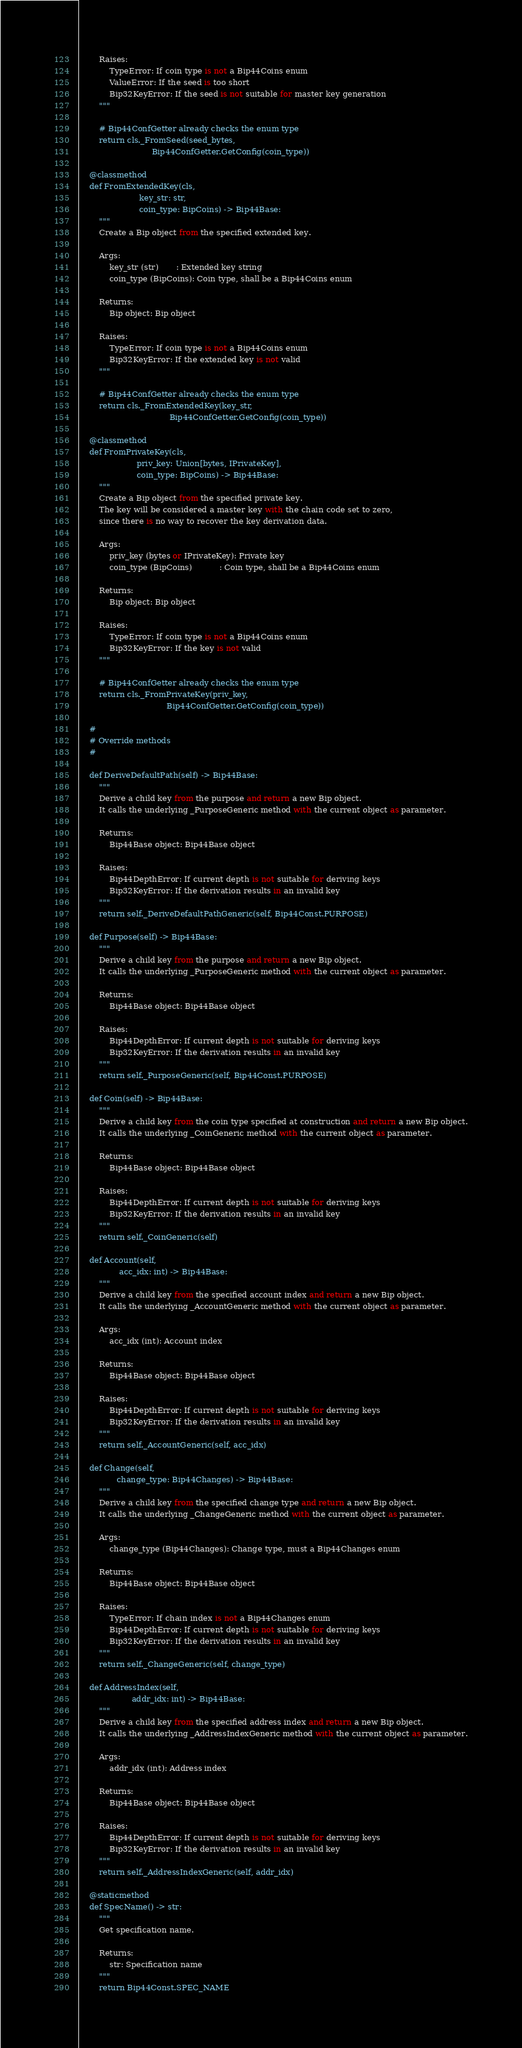<code> <loc_0><loc_0><loc_500><loc_500><_Python_>
        Raises:
            TypeError: If coin type is not a Bip44Coins enum
            ValueError: If the seed is too short
            Bip32KeyError: If the seed is not suitable for master key generation
        """

        # Bip44ConfGetter already checks the enum type
        return cls._FromSeed(seed_bytes,
                             Bip44ConfGetter.GetConfig(coin_type))

    @classmethod
    def FromExtendedKey(cls,
                        key_str: str,
                        coin_type: BipCoins) -> Bip44Base:
        """
        Create a Bip object from the specified extended key.

        Args:
            key_str (str)       : Extended key string
            coin_type (BipCoins): Coin type, shall be a Bip44Coins enum

        Returns:
            Bip object: Bip object

        Raises:
            TypeError: If coin type is not a Bip44Coins enum
            Bip32KeyError: If the extended key is not valid
        """

        # Bip44ConfGetter already checks the enum type
        return cls._FromExtendedKey(key_str,
                                    Bip44ConfGetter.GetConfig(coin_type))

    @classmethod
    def FromPrivateKey(cls,
                       priv_key: Union[bytes, IPrivateKey],
                       coin_type: BipCoins) -> Bip44Base:
        """
        Create a Bip object from the specified private key.
        The key will be considered a master key with the chain code set to zero,
        since there is no way to recover the key derivation data.

        Args:
            priv_key (bytes or IPrivateKey): Private key
            coin_type (BipCoins)           : Coin type, shall be a Bip44Coins enum

        Returns:
            Bip object: Bip object

        Raises:
            TypeError: If coin type is not a Bip44Coins enum
            Bip32KeyError: If the key is not valid
        """

        # Bip44ConfGetter already checks the enum type
        return cls._FromPrivateKey(priv_key,
                                   Bip44ConfGetter.GetConfig(coin_type))

    #
    # Override methods
    #

    def DeriveDefaultPath(self) -> Bip44Base:
        """
        Derive a child key from the purpose and return a new Bip object.
        It calls the underlying _PurposeGeneric method with the current object as parameter.

        Returns:
            Bip44Base object: Bip44Base object

        Raises:
            Bip44DepthError: If current depth is not suitable for deriving keys
            Bip32KeyError: If the derivation results in an invalid key
        """
        return self._DeriveDefaultPathGeneric(self, Bip44Const.PURPOSE)

    def Purpose(self) -> Bip44Base:
        """
        Derive a child key from the purpose and return a new Bip object.
        It calls the underlying _PurposeGeneric method with the current object as parameter.

        Returns:
            Bip44Base object: Bip44Base object

        Raises:
            Bip44DepthError: If current depth is not suitable for deriving keys
            Bip32KeyError: If the derivation results in an invalid key
        """
        return self._PurposeGeneric(self, Bip44Const.PURPOSE)

    def Coin(self) -> Bip44Base:
        """
        Derive a child key from the coin type specified at construction and return a new Bip object.
        It calls the underlying _CoinGeneric method with the current object as parameter.

        Returns:
            Bip44Base object: Bip44Base object

        Raises:
            Bip44DepthError: If current depth is not suitable for deriving keys
            Bip32KeyError: If the derivation results in an invalid key
        """
        return self._CoinGeneric(self)

    def Account(self,
                acc_idx: int) -> Bip44Base:
        """
        Derive a child key from the specified account index and return a new Bip object.
        It calls the underlying _AccountGeneric method with the current object as parameter.

        Args:
            acc_idx (int): Account index

        Returns:
            Bip44Base object: Bip44Base object

        Raises:
            Bip44DepthError: If current depth is not suitable for deriving keys
            Bip32KeyError: If the derivation results in an invalid key
        """
        return self._AccountGeneric(self, acc_idx)

    def Change(self,
               change_type: Bip44Changes) -> Bip44Base:
        """
        Derive a child key from the specified change type and return a new Bip object.
        It calls the underlying _ChangeGeneric method with the current object as parameter.

        Args:
            change_type (Bip44Changes): Change type, must a Bip44Changes enum

        Returns:
            Bip44Base object: Bip44Base object

        Raises:
            TypeError: If chain index is not a Bip44Changes enum
            Bip44DepthError: If current depth is not suitable for deriving keys
            Bip32KeyError: If the derivation results in an invalid key
        """
        return self._ChangeGeneric(self, change_type)

    def AddressIndex(self,
                     addr_idx: int) -> Bip44Base:
        """
        Derive a child key from the specified address index and return a new Bip object.
        It calls the underlying _AddressIndexGeneric method with the current object as parameter.

        Args:
            addr_idx (int): Address index

        Returns:
            Bip44Base object: Bip44Base object

        Raises:
            Bip44DepthError: If current depth is not suitable for deriving keys
            Bip32KeyError: If the derivation results in an invalid key
        """
        return self._AddressIndexGeneric(self, addr_idx)

    @staticmethod
    def SpecName() -> str:
        """
        Get specification name.

        Returns:
            str: Specification name
        """
        return Bip44Const.SPEC_NAME
</code> 